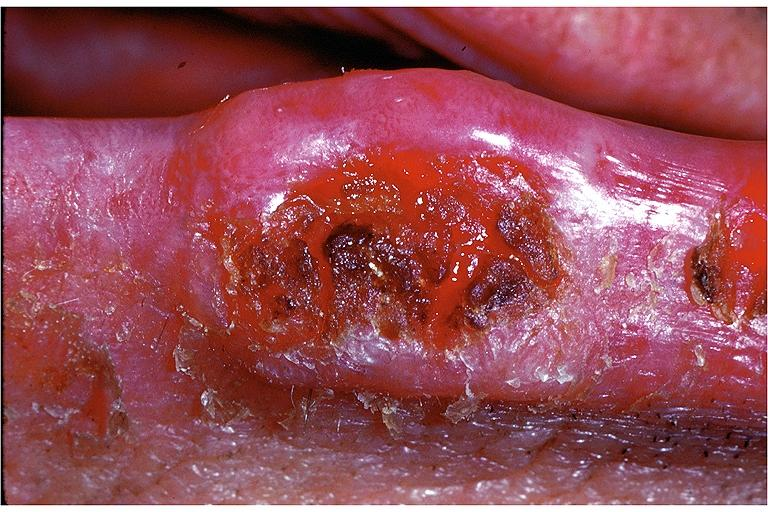s oral present?
Answer the question using a single word or phrase. Yes 